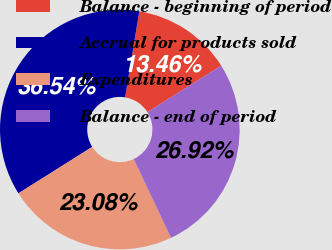Convert chart to OTSL. <chart><loc_0><loc_0><loc_500><loc_500><pie_chart><fcel>Balance - beginning of period<fcel>Accrual for products sold<fcel>Expenditures<fcel>Balance - end of period<nl><fcel>13.46%<fcel>36.54%<fcel>23.08%<fcel>26.92%<nl></chart> 